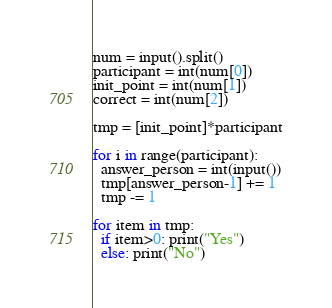<code> <loc_0><loc_0><loc_500><loc_500><_Python_>num = input().split()
participant = int(num[0])
init_point = int(num[1])
correct = int(num[2])

tmp = [init_point]*participant

for i in range(participant):
  answer_person = int(input())
  tmp[answer_person-1] += 1
  tmp -= 1
  
for item in tmp:
  if item>0: print("Yes")
  else: print("No")</code> 